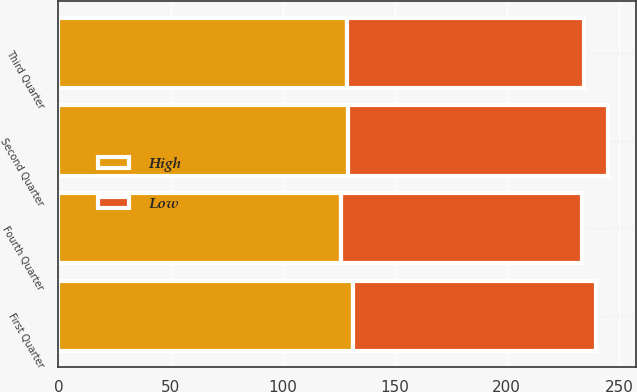Convert chart. <chart><loc_0><loc_0><loc_500><loc_500><stacked_bar_chart><ecel><fcel>First Quarter<fcel>Second Quarter<fcel>Third Quarter<fcel>Fourth Quarter<nl><fcel>High<fcel>131.19<fcel>129.33<fcel>128.84<fcel>126.24<nl><fcel>Low<fcel>108.73<fcel>116<fcel>105.77<fcel>107.3<nl></chart> 